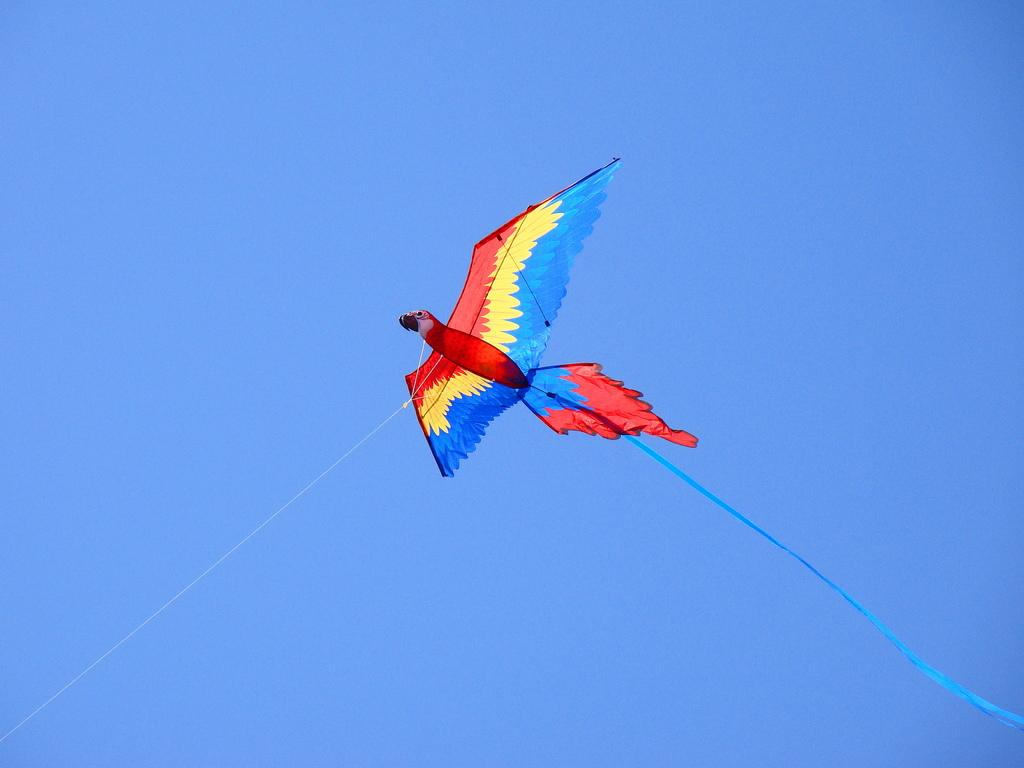What is the main object in the image? There is a kite in the image. How is the kite connected to the ground? The kite has threads that connect it to the ground. What decorative element is attached to the kite? The kite has a ribbon. Where is the kite located in the image? The kite is in the air. What can be seen in the background of the image? The background of the image is a clear sky. How many boys are holding the rod in the image? There is no rod or boys present in the image; it features a kite in the air with threads and a ribbon. 